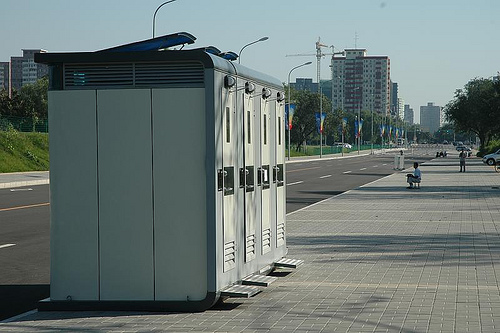<image>
Is there a portable toilet next to the sidewalk? Yes. The portable toilet is positioned adjacent to the sidewalk, located nearby in the same general area. 